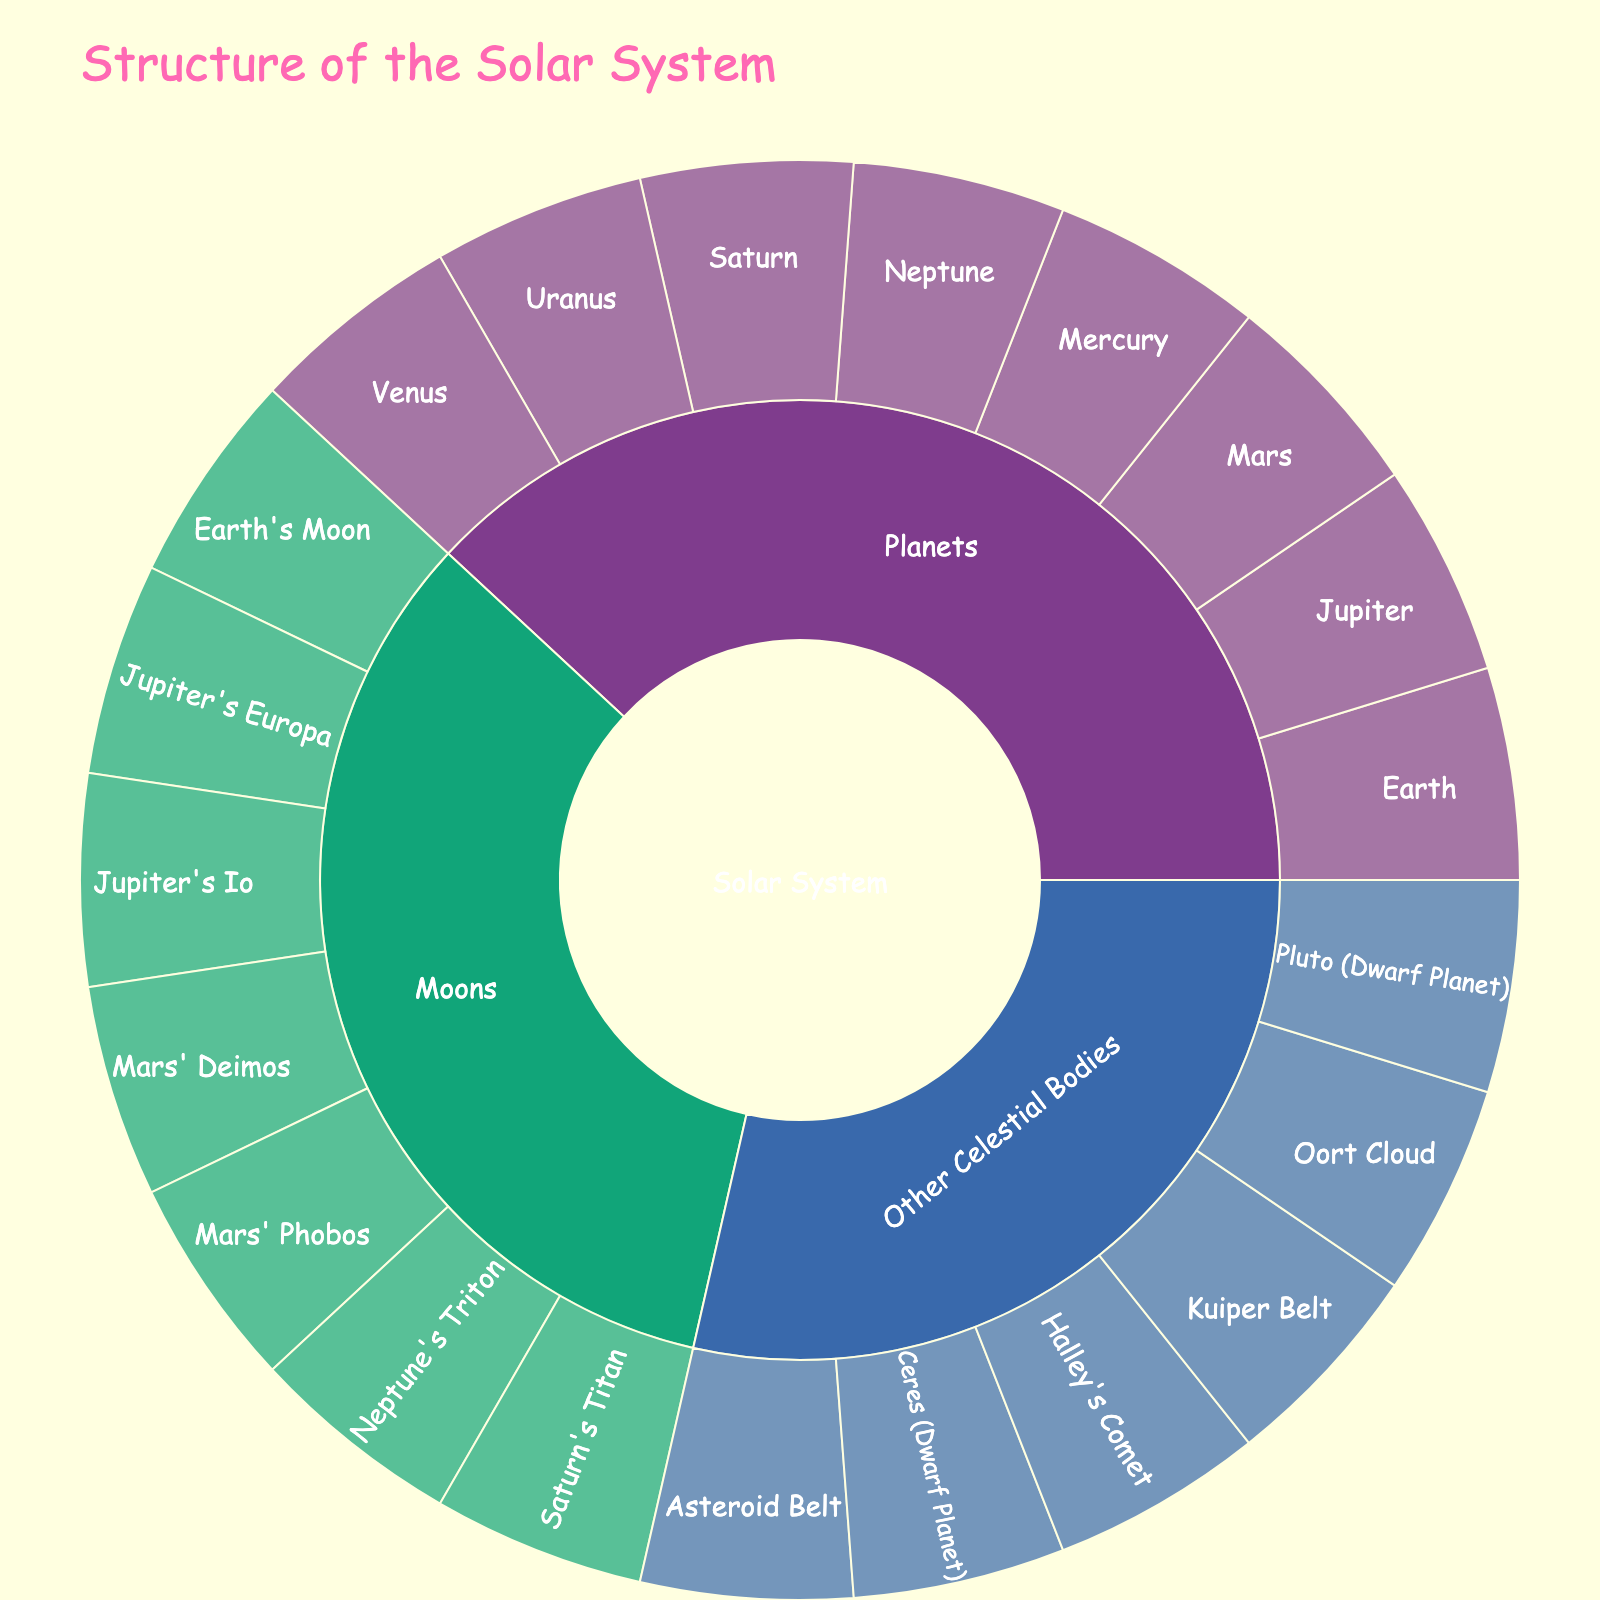What's the title of the sunburst plot? The title is displayed at the top of the plot, above all other elements.
Answer: Structure of the Solar System What are the main categories in the sunburst plot? The main categories are the first outer ring of the sunburst plot, directly connected to the center, labeled "Solar System". These categories are "Planets", "Moons", and "Other Celestial Bodies".
Answer: Planets, Moons, Other Celestial Bodies How many planets are represented in the sunburst plot? In the section labeled "Planets", there are individual segments for each of the planets within our solar system. Counting these segments reveals the total number of planets displayed.
Answer: 8 Which planet's moon is labeled "Europa"? In the section labeled "Moons", find the subsections labeled with different planets' names followed by their moon names. "Europa" is listed under "Jupiter".
Answer: Jupiter How many moons does Mars have listed in the plot? Check the "Moons" section for the subsections under "Mars". Sum the number of individuals within the Mars subsection, which is "Phobos" and "Deimos".
Answer: 2 Which category has the most individual items represented? Count the individual items within each main category: "Planets", "Moons", and "Other Celestial Bodies". Compare these counts.
Answer: Other Celestial Bodies What's the value assigned to each item in the sunburst plot? Each item in the plot has a value indicated in the plot, usually displayed in hover data or segmentation size. Here, each item has a value of 1.
Answer: 1 Are there more moons or other celestial bodies listed in the sunburst plot? Count individual moon entries and other celestial bodies entries. Compare these counts to determine which is greater.
Answer: Other Celestial Bodies Which moon of Saturn is listed in the plot? Look under the "Moons" section for the Saturn subsection and identify its moon.
Answer: Titan What are the five types of other celestial bodies represented? Identify the subcategories under the "Other Celestial Bodies" section. They are the outermost subcategories represented.
Answer: Asteroid Belt, Kuiper Belt, Oort Cloud, Halley's Comet, Ceres (Dwarf Planet), Pluto (Dwarf Planet) 